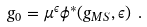Convert formula to latex. <formula><loc_0><loc_0><loc_500><loc_500>g _ { 0 } = \mu ^ { \epsilon } \phi ^ { * } ( g _ { M S } , \epsilon ) \ .</formula> 